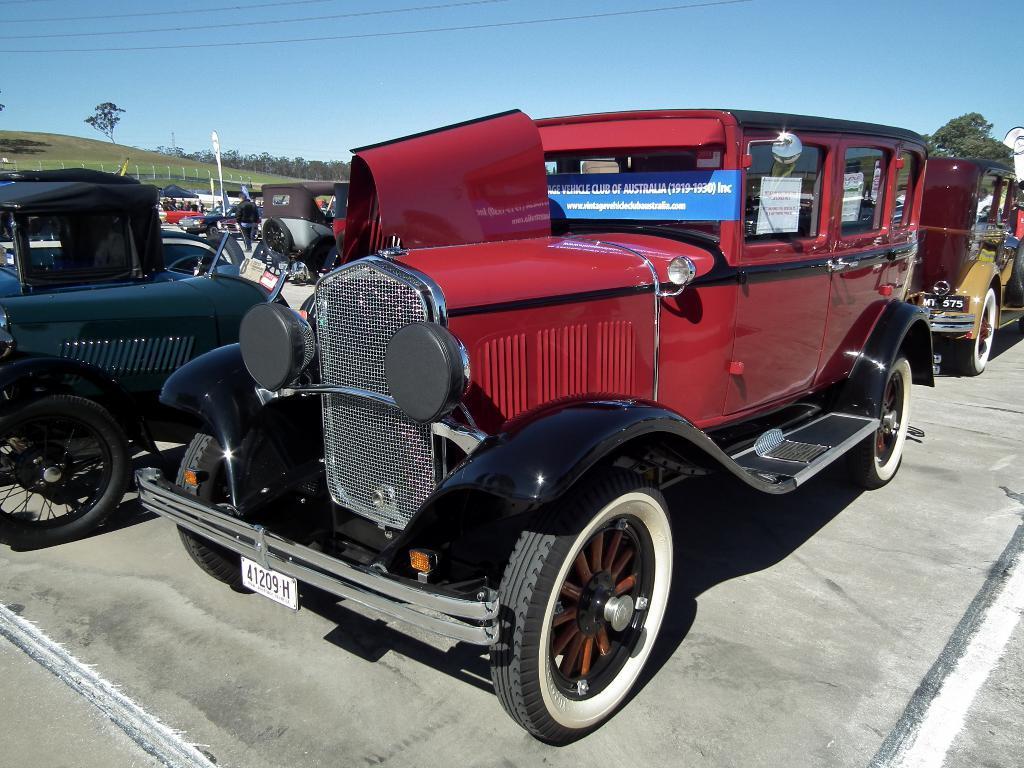In one or two sentences, can you explain what this image depicts? This picture is clicked outside. In the center we can see the group of vehicles parked on the ground. In the background we can see the sky, trees and the green grass. 